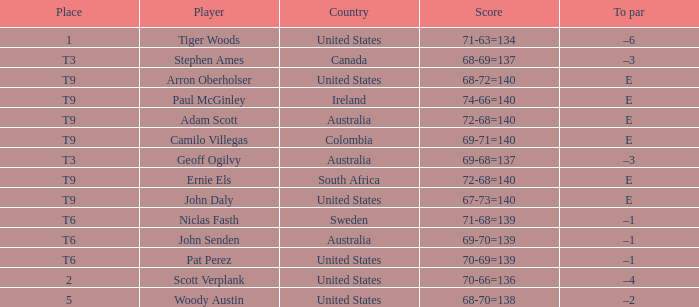What is Canada's score? 68-69=137. 